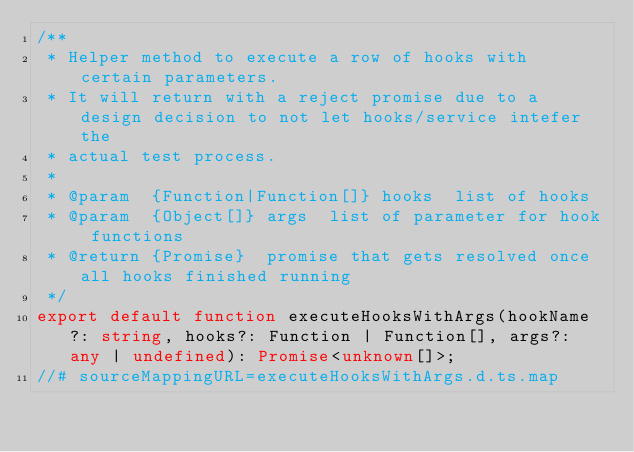Convert code to text. <code><loc_0><loc_0><loc_500><loc_500><_TypeScript_>/**
 * Helper method to execute a row of hooks with certain parameters.
 * It will return with a reject promise due to a design decision to not let hooks/service intefer the
 * actual test process.
 *
 * @param  {Function|Function[]} hooks  list of hooks
 * @param  {Object[]} args  list of parameter for hook functions
 * @return {Promise}  promise that gets resolved once all hooks finished running
 */
export default function executeHooksWithArgs(hookName?: string, hooks?: Function | Function[], args?: any | undefined): Promise<unknown[]>;
//# sourceMappingURL=executeHooksWithArgs.d.ts.map</code> 